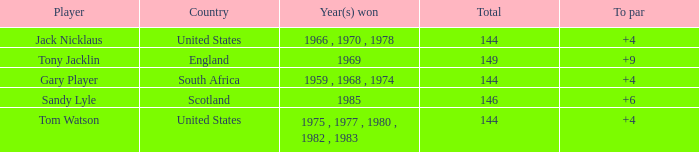What was Tom Watson's lowest To par when the total was larger than 144? None. 